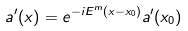Convert formula to latex. <formula><loc_0><loc_0><loc_500><loc_500>a ^ { \prime } ( x ) = e ^ { - i E ^ { m } ( x - x _ { 0 } ) } a ^ { \prime } ( x _ { 0 } )</formula> 